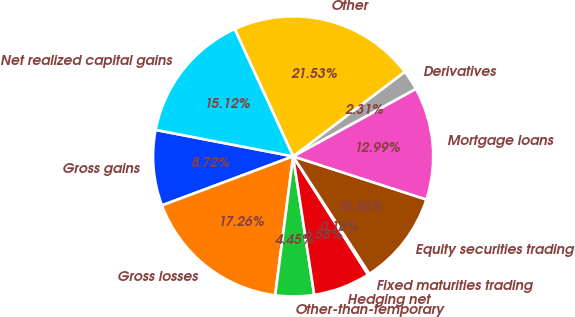<chart> <loc_0><loc_0><loc_500><loc_500><pie_chart><fcel>Gross gains<fcel>Gross losses<fcel>Other-than-temporary<fcel>Hedging net<fcel>Fixed maturities trading<fcel>Equity securities trading<fcel>Mortgage loans<fcel>Derivatives<fcel>Other<fcel>Net realized capital gains<nl><fcel>8.72%<fcel>17.26%<fcel>4.45%<fcel>6.58%<fcel>0.18%<fcel>10.85%<fcel>12.99%<fcel>2.31%<fcel>21.53%<fcel>15.12%<nl></chart> 